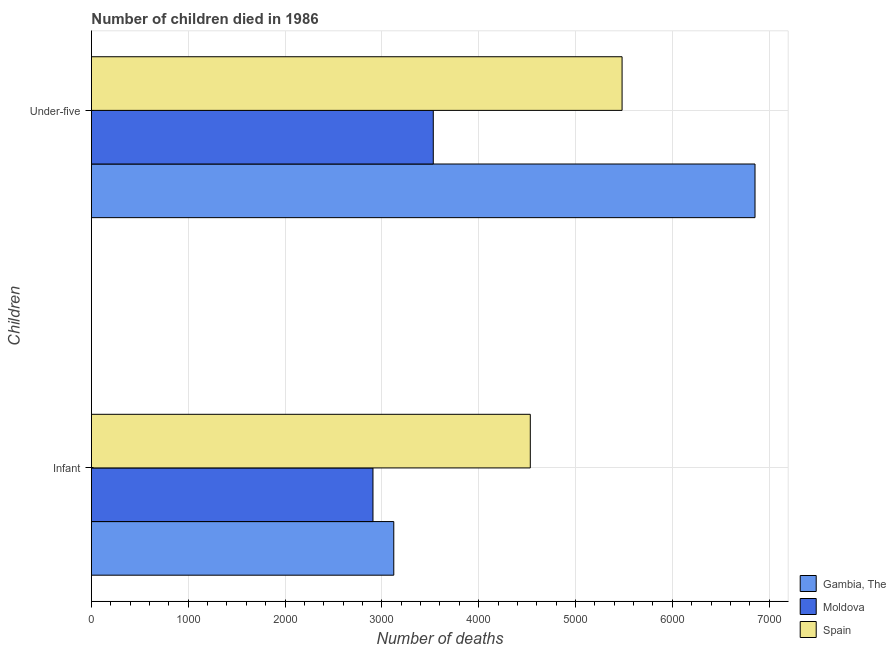Are the number of bars per tick equal to the number of legend labels?
Your answer should be compact. Yes. Are the number of bars on each tick of the Y-axis equal?
Offer a very short reply. Yes. What is the label of the 2nd group of bars from the top?
Provide a succinct answer. Infant. What is the number of infant deaths in Spain?
Your answer should be compact. 4533. Across all countries, what is the maximum number of under-five deaths?
Provide a succinct answer. 6854. Across all countries, what is the minimum number of infant deaths?
Offer a terse response. 2908. In which country was the number of infant deaths maximum?
Your response must be concise. Spain. In which country was the number of under-five deaths minimum?
Offer a very short reply. Moldova. What is the total number of under-five deaths in the graph?
Provide a succinct answer. 1.59e+04. What is the difference between the number of under-five deaths in Spain and that in Gambia, The?
Your answer should be very brief. -1373. What is the difference between the number of infant deaths in Moldova and the number of under-five deaths in Spain?
Offer a very short reply. -2573. What is the average number of infant deaths per country?
Provide a short and direct response. 3521.33. What is the difference between the number of under-five deaths and number of infant deaths in Spain?
Make the answer very short. 948. In how many countries, is the number of infant deaths greater than 6200 ?
Offer a terse response. 0. What is the ratio of the number of under-five deaths in Gambia, The to that in Moldova?
Offer a terse response. 1.94. What does the 3rd bar from the bottom in Under-five represents?
Ensure brevity in your answer.  Spain. Are all the bars in the graph horizontal?
Keep it short and to the point. Yes. How many countries are there in the graph?
Keep it short and to the point. 3. What is the difference between two consecutive major ticks on the X-axis?
Keep it short and to the point. 1000. Are the values on the major ticks of X-axis written in scientific E-notation?
Give a very brief answer. No. Where does the legend appear in the graph?
Your answer should be very brief. Bottom right. How many legend labels are there?
Your answer should be very brief. 3. How are the legend labels stacked?
Your response must be concise. Vertical. What is the title of the graph?
Give a very brief answer. Number of children died in 1986. Does "Romania" appear as one of the legend labels in the graph?
Offer a terse response. No. What is the label or title of the X-axis?
Give a very brief answer. Number of deaths. What is the label or title of the Y-axis?
Offer a terse response. Children. What is the Number of deaths of Gambia, The in Infant?
Provide a succinct answer. 3123. What is the Number of deaths in Moldova in Infant?
Your response must be concise. 2908. What is the Number of deaths in Spain in Infant?
Offer a terse response. 4533. What is the Number of deaths of Gambia, The in Under-five?
Offer a very short reply. 6854. What is the Number of deaths in Moldova in Under-five?
Provide a short and direct response. 3531. What is the Number of deaths of Spain in Under-five?
Your answer should be compact. 5481. Across all Children, what is the maximum Number of deaths in Gambia, The?
Your answer should be very brief. 6854. Across all Children, what is the maximum Number of deaths in Moldova?
Provide a short and direct response. 3531. Across all Children, what is the maximum Number of deaths of Spain?
Provide a succinct answer. 5481. Across all Children, what is the minimum Number of deaths in Gambia, The?
Ensure brevity in your answer.  3123. Across all Children, what is the minimum Number of deaths in Moldova?
Make the answer very short. 2908. Across all Children, what is the minimum Number of deaths of Spain?
Offer a very short reply. 4533. What is the total Number of deaths in Gambia, The in the graph?
Offer a terse response. 9977. What is the total Number of deaths in Moldova in the graph?
Your answer should be compact. 6439. What is the total Number of deaths in Spain in the graph?
Keep it short and to the point. 1.00e+04. What is the difference between the Number of deaths in Gambia, The in Infant and that in Under-five?
Provide a succinct answer. -3731. What is the difference between the Number of deaths of Moldova in Infant and that in Under-five?
Give a very brief answer. -623. What is the difference between the Number of deaths in Spain in Infant and that in Under-five?
Provide a succinct answer. -948. What is the difference between the Number of deaths of Gambia, The in Infant and the Number of deaths of Moldova in Under-five?
Your answer should be compact. -408. What is the difference between the Number of deaths in Gambia, The in Infant and the Number of deaths in Spain in Under-five?
Provide a short and direct response. -2358. What is the difference between the Number of deaths of Moldova in Infant and the Number of deaths of Spain in Under-five?
Provide a succinct answer. -2573. What is the average Number of deaths of Gambia, The per Children?
Your answer should be compact. 4988.5. What is the average Number of deaths of Moldova per Children?
Make the answer very short. 3219.5. What is the average Number of deaths of Spain per Children?
Make the answer very short. 5007. What is the difference between the Number of deaths in Gambia, The and Number of deaths in Moldova in Infant?
Keep it short and to the point. 215. What is the difference between the Number of deaths of Gambia, The and Number of deaths of Spain in Infant?
Your answer should be compact. -1410. What is the difference between the Number of deaths of Moldova and Number of deaths of Spain in Infant?
Offer a very short reply. -1625. What is the difference between the Number of deaths in Gambia, The and Number of deaths in Moldova in Under-five?
Ensure brevity in your answer.  3323. What is the difference between the Number of deaths in Gambia, The and Number of deaths in Spain in Under-five?
Keep it short and to the point. 1373. What is the difference between the Number of deaths in Moldova and Number of deaths in Spain in Under-five?
Make the answer very short. -1950. What is the ratio of the Number of deaths of Gambia, The in Infant to that in Under-five?
Make the answer very short. 0.46. What is the ratio of the Number of deaths of Moldova in Infant to that in Under-five?
Your answer should be very brief. 0.82. What is the ratio of the Number of deaths in Spain in Infant to that in Under-five?
Your answer should be very brief. 0.83. What is the difference between the highest and the second highest Number of deaths in Gambia, The?
Your answer should be compact. 3731. What is the difference between the highest and the second highest Number of deaths of Moldova?
Make the answer very short. 623. What is the difference between the highest and the second highest Number of deaths in Spain?
Your response must be concise. 948. What is the difference between the highest and the lowest Number of deaths in Gambia, The?
Ensure brevity in your answer.  3731. What is the difference between the highest and the lowest Number of deaths of Moldova?
Your response must be concise. 623. What is the difference between the highest and the lowest Number of deaths of Spain?
Give a very brief answer. 948. 